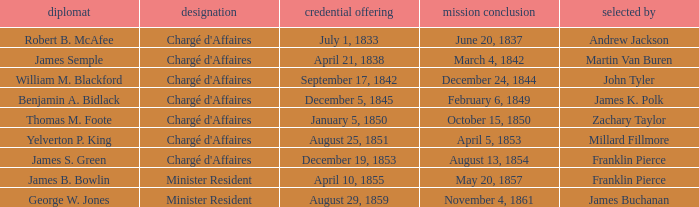What's the Representative listed that has a Presentation of Credentials of August 25, 1851? Yelverton P. King. 